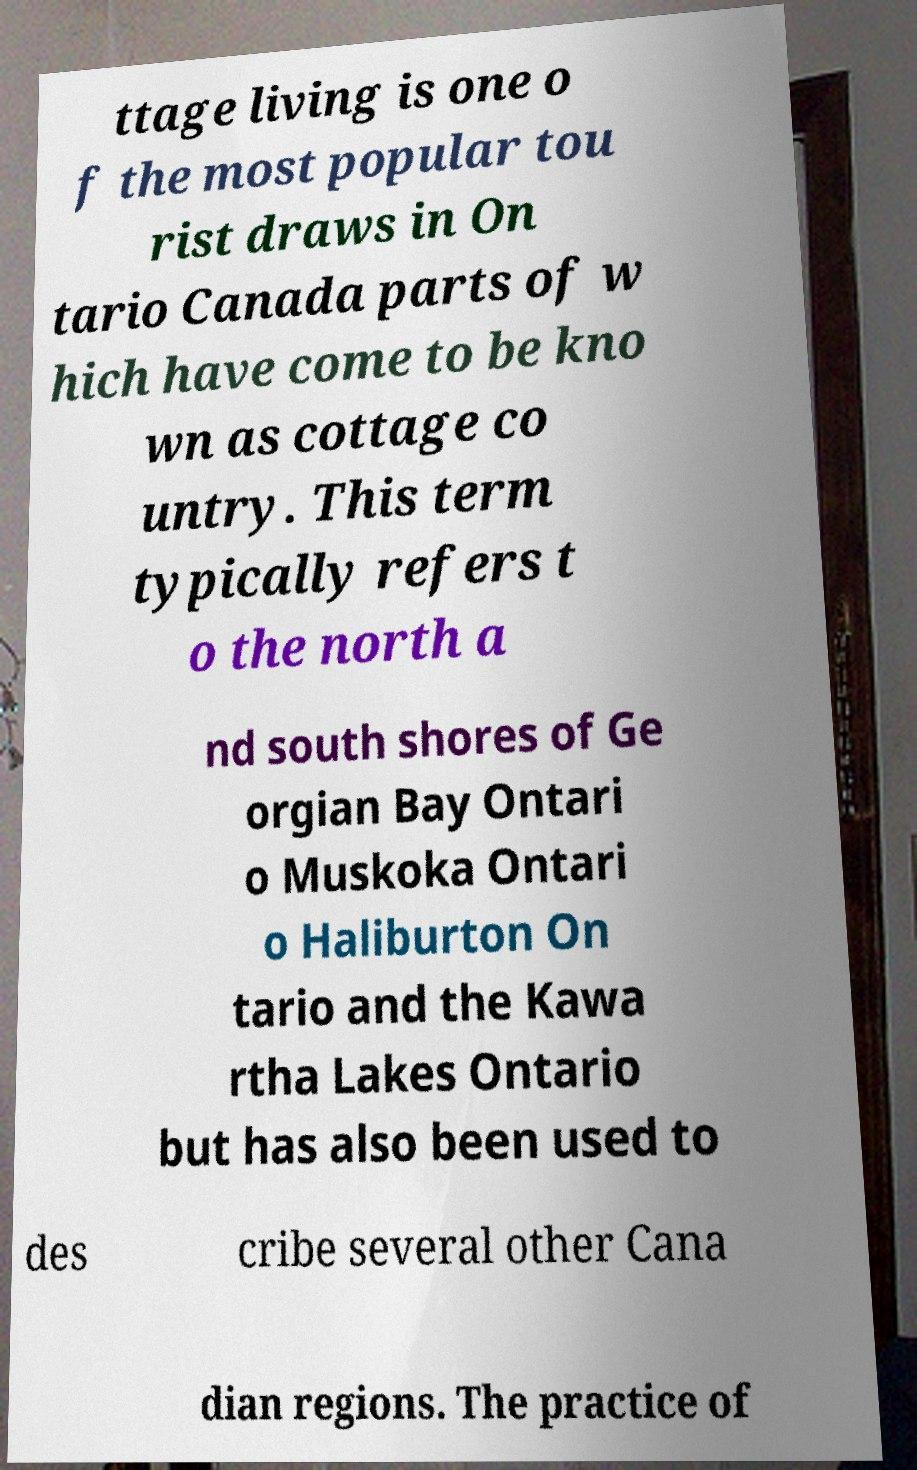Could you assist in decoding the text presented in this image and type it out clearly? ttage living is one o f the most popular tou rist draws in On tario Canada parts of w hich have come to be kno wn as cottage co untry. This term typically refers t o the north a nd south shores of Ge orgian Bay Ontari o Muskoka Ontari o Haliburton On tario and the Kawa rtha Lakes Ontario but has also been used to des cribe several other Cana dian regions. The practice of 